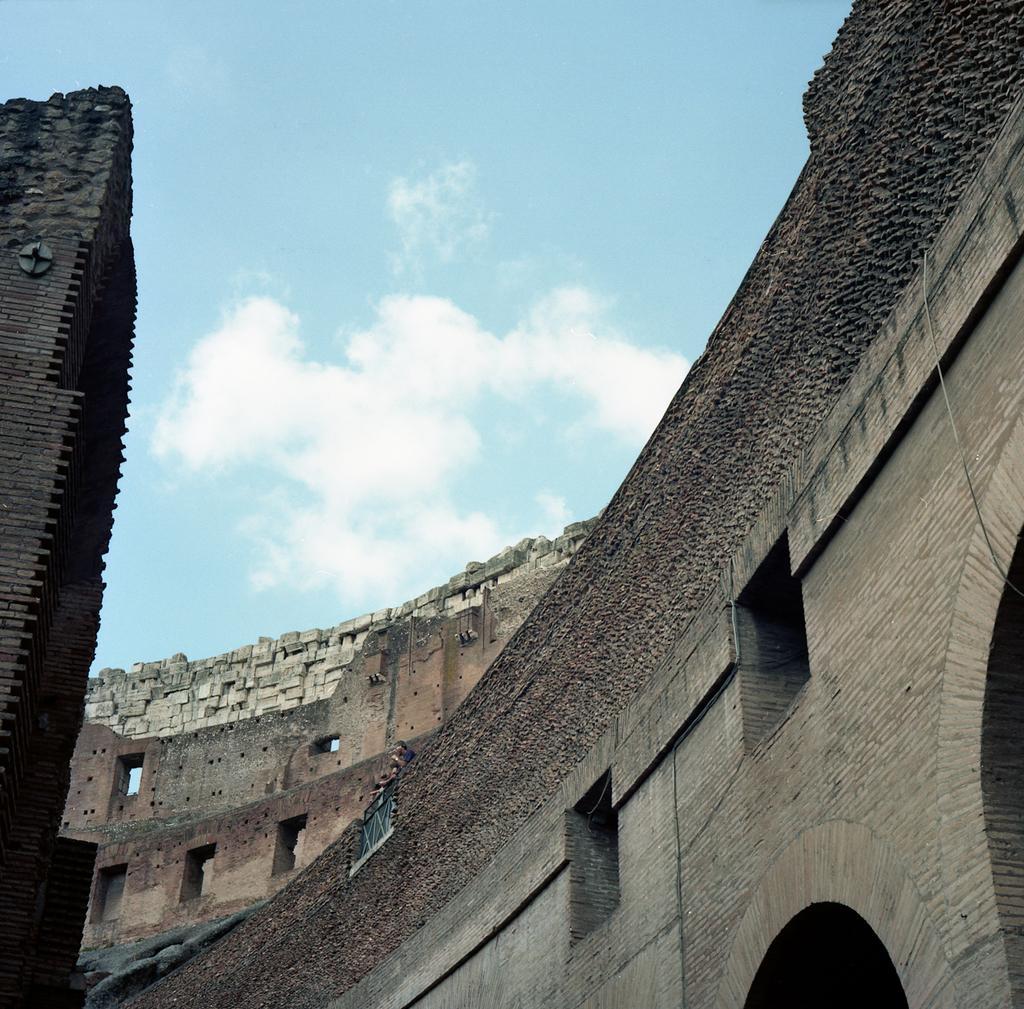How would you summarize this image in a sentence or two? In this image there is a building, at the top of the image there are clouds in the sky. 